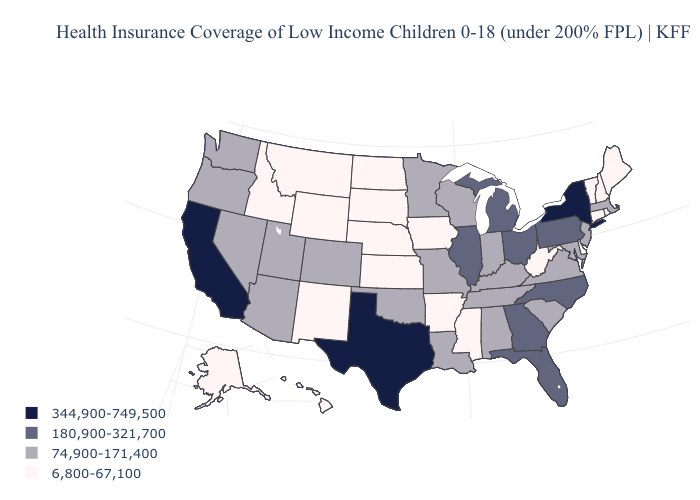What is the lowest value in states that border West Virginia?
Quick response, please. 74,900-171,400. Name the states that have a value in the range 180,900-321,700?
Concise answer only. Florida, Georgia, Illinois, Michigan, North Carolina, Ohio, Pennsylvania. What is the lowest value in the Northeast?
Give a very brief answer. 6,800-67,100. Which states have the lowest value in the USA?
Give a very brief answer. Alaska, Arkansas, Connecticut, Delaware, Hawaii, Idaho, Iowa, Kansas, Maine, Mississippi, Montana, Nebraska, New Hampshire, New Mexico, North Dakota, Rhode Island, South Dakota, Vermont, West Virginia, Wyoming. What is the value of Arkansas?
Write a very short answer. 6,800-67,100. What is the value of Washington?
Short answer required. 74,900-171,400. Among the states that border Florida , which have the highest value?
Concise answer only. Georgia. Does New Jersey have a higher value than West Virginia?
Answer briefly. Yes. Does the map have missing data?
Answer briefly. No. What is the value of Vermont?
Give a very brief answer. 6,800-67,100. Does Illinois have the highest value in the MidWest?
Give a very brief answer. Yes. What is the value of Nevada?
Be succinct. 74,900-171,400. What is the value of Georgia?
Concise answer only. 180,900-321,700. What is the highest value in the USA?
Short answer required. 344,900-749,500. Which states have the lowest value in the USA?
Answer briefly. Alaska, Arkansas, Connecticut, Delaware, Hawaii, Idaho, Iowa, Kansas, Maine, Mississippi, Montana, Nebraska, New Hampshire, New Mexico, North Dakota, Rhode Island, South Dakota, Vermont, West Virginia, Wyoming. 